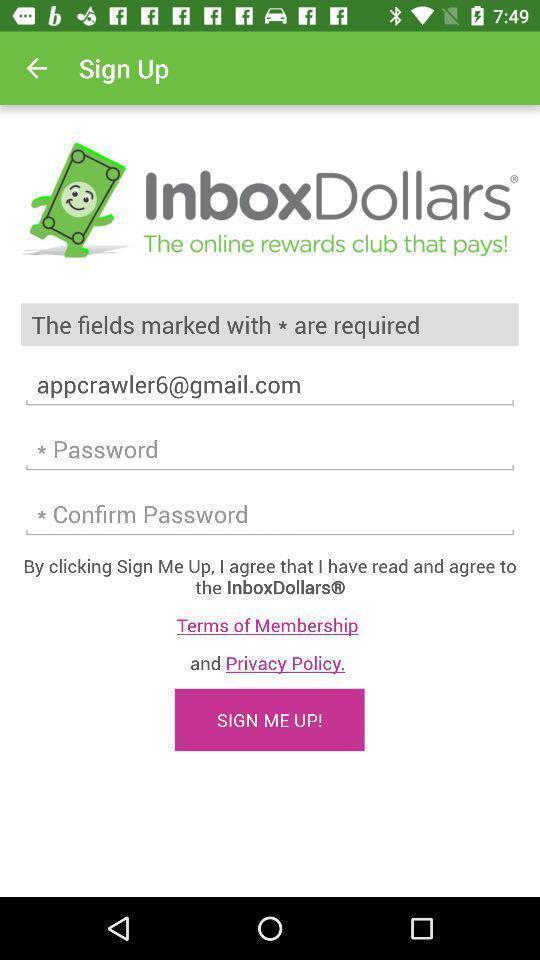Please provide a description for this image. Sign up page. 